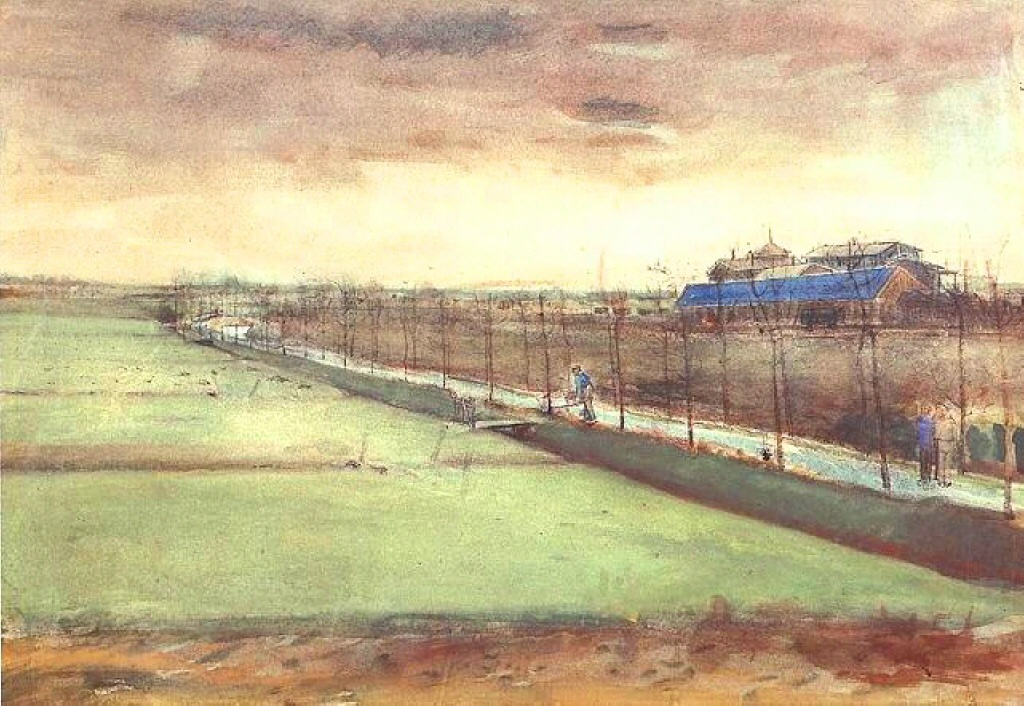Can you tell me more about the building with the blue roof in this painting? The building with the blue roof appears to be a farmhouse or a barn, characteristic of rural architectural styles. Its vivid blue roof stands out against the earthy tones of the landscape, serving as a focal point in the composition. This structure could be a gathering place for farm activities or a shelter for animals, playing a central role in the rural life depicted in this artwork. 